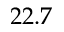<formula> <loc_0><loc_0><loc_500><loc_500>2 2 . 7</formula> 